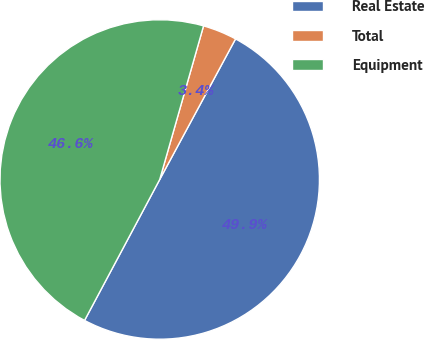Convert chart. <chart><loc_0><loc_0><loc_500><loc_500><pie_chart><fcel>Real Estate<fcel>Total<fcel>Equipment<nl><fcel>49.93%<fcel>3.45%<fcel>46.63%<nl></chart> 